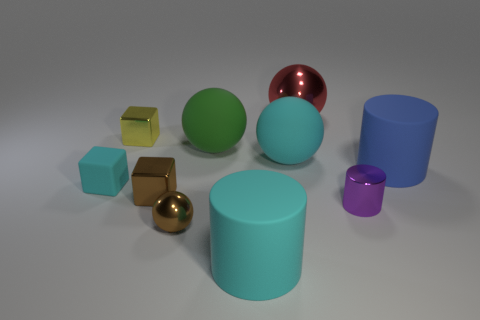Subtract all brown spheres. How many spheres are left? 3 Subtract all rubber cylinders. How many cylinders are left? 1 Subtract 1 cylinders. How many cylinders are left? 2 Subtract all cylinders. How many objects are left? 7 Subtract all gray spheres. Subtract all yellow blocks. How many spheres are left? 4 Subtract all large purple balls. Subtract all red objects. How many objects are left? 9 Add 5 purple cylinders. How many purple cylinders are left? 6 Add 7 large cyan balls. How many large cyan balls exist? 8 Subtract 0 red cubes. How many objects are left? 10 